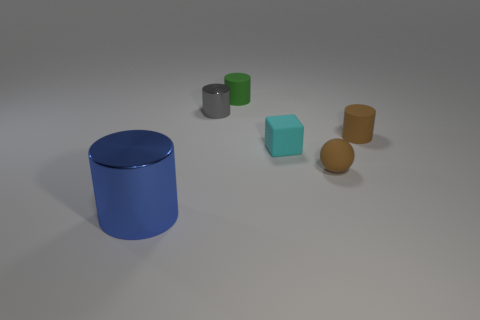Subtract all small green matte cylinders. How many cylinders are left? 3 Subtract all blue cylinders. How many cylinders are left? 3 Add 1 metallic things. How many objects exist? 7 Subtract 3 cylinders. How many cylinders are left? 1 Subtract all cylinders. How many objects are left? 2 Subtract 1 gray cylinders. How many objects are left? 5 Subtract all gray balls. Subtract all brown blocks. How many balls are left? 1 Subtract all large blue cylinders. Subtract all small brown matte cylinders. How many objects are left? 4 Add 3 gray metallic cylinders. How many gray metallic cylinders are left? 4 Add 6 large objects. How many large objects exist? 7 